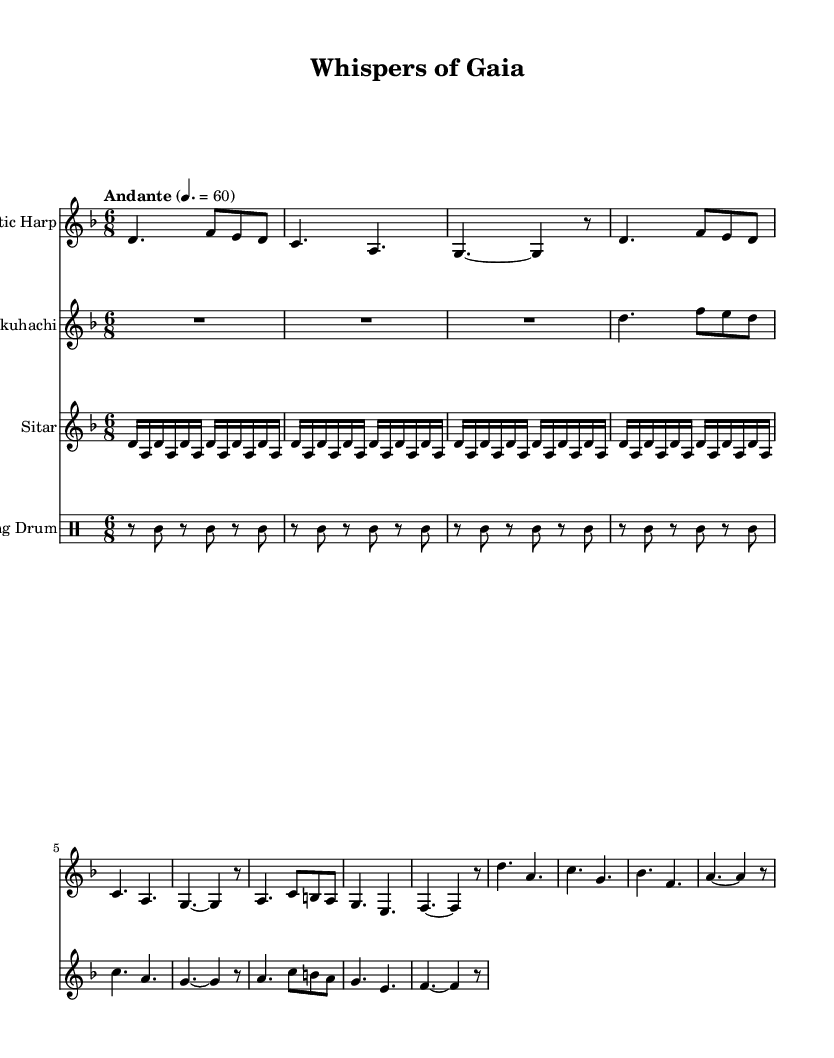What is the key signature of this music? The key signature is indicated at the beginning of the score. In this case, we can see that there is a B flat in the key signature, indicating that the music is in D minor.
Answer: D minor What is the time signature of this music? The time signature is located at the beginning, and here it is written as 6/8. This means there are six eighth notes per measure.
Answer: 6/8 What is the tempo marking of this piece? The tempo marking is indicated below the global section, stating "Andante" and a metronome marking of 60 beats per minute. This suggests a moderate tempo.
Answer: Andante Which traditional instruments are used in this piece? By analyzing the staff names, we can identify the instruments, which are the Celtic Harp, Shakuhachi, Sitar, and Hang Drum.
Answer: Celtic Harp, Shakuhachi, Sitar, Hang Drum How many measures does the Hang Drum part have? Looking at the Hang Drum staff, it shows a repeating pattern which is made up of 4 measures of music, each consisting of 4 counts of rests and notes. So, it has a total of 4 measures.
Answer: 4 measures Which instrument has a descending melodic line in its part? In the parts presented, we can see that the Shakuhachi line prominently features descending notes, particularly in measures where it follows the contour of the notes.
Answer: Shakuhachi How does the rhythm change between the Harp and Sitar parts? By examining the patterns, the Harp part has a more flowing rhythm influenced by triplet groups, while the Sitar utilizes repetitive sixteenth notes creating a steadier rhythm. This contrast enhances the ethereal quality of the piece.
Answer: Triplet vs. steady rhythm 